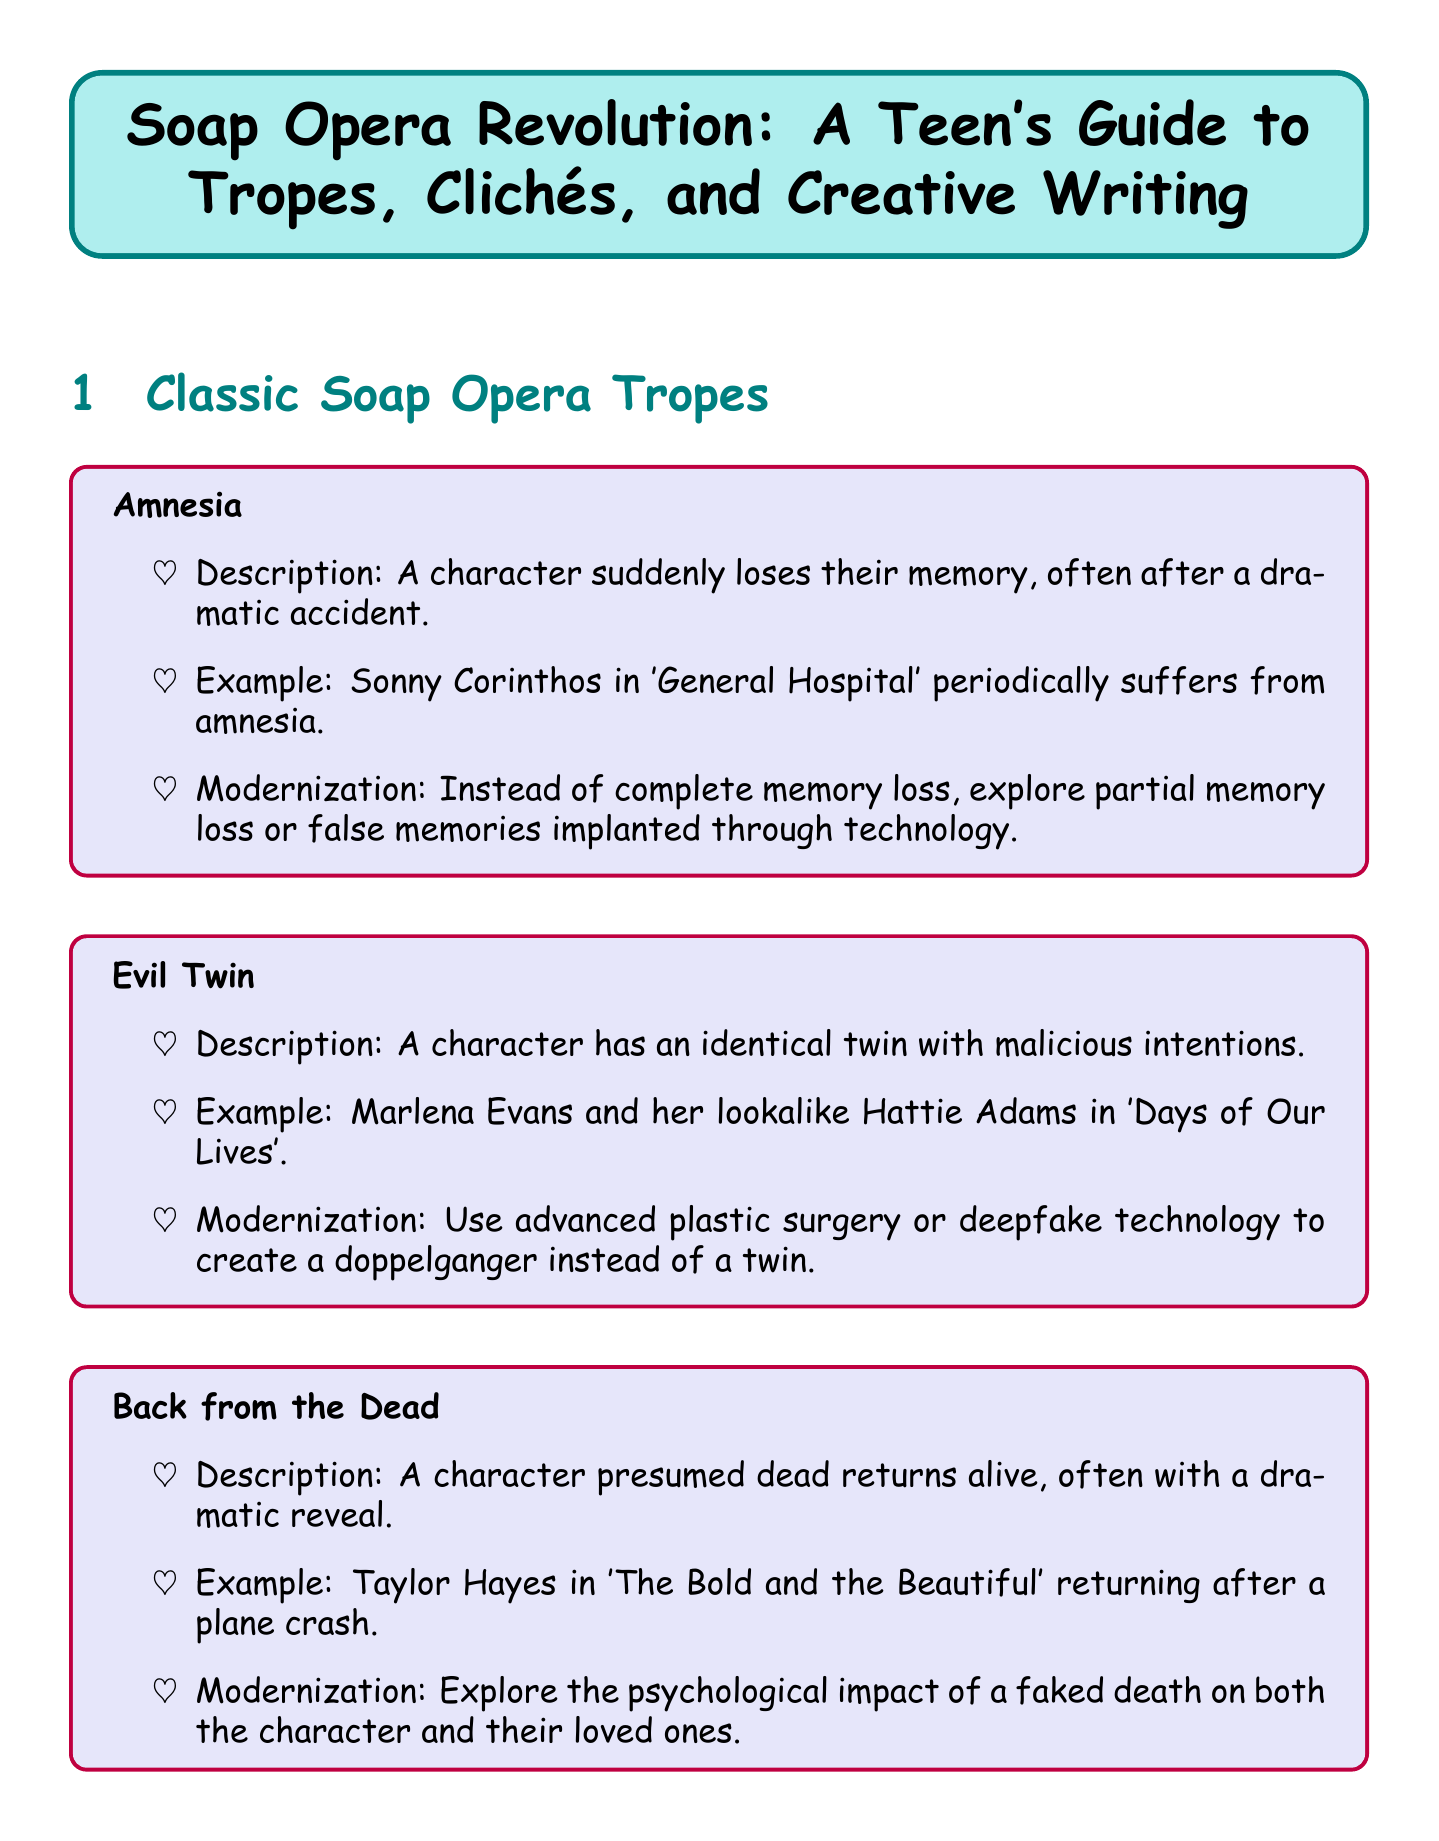What is the title of the document? The title is stated at the very beginning of the document, providing essential identification for the guide.
Answer: Soap Opera Revolution: A Teen's Guide to Tropes, Clichés, and Creative Writing How many classic soap opera tropes are listed? The document lists three classic soap opera tropes, detailed under the corresponding section.
Answer: 3 What is the example given for the trope "Back from the Dead"? The example associated with the "Back from the Dead" trope highlights a specific character and scenario from a well-known soap opera.
Answer: Taylor Hayes in 'The Bold and the Beautiful' returning after a plane crash What technique suggests using social media in storylines? The document outlines specific writing techniques, with one technique focusing on social media's role in advancing plots.
Answer: Social Media Integration What is a suggested way to modernize the "Evil Twin" trope? This question involves understanding how to update classic tropes, specifically looking for modern technologies mentioned in the document.
Answer: Use advanced plastic surgery or deepfake technology to create a doppelganger instead of a twin 